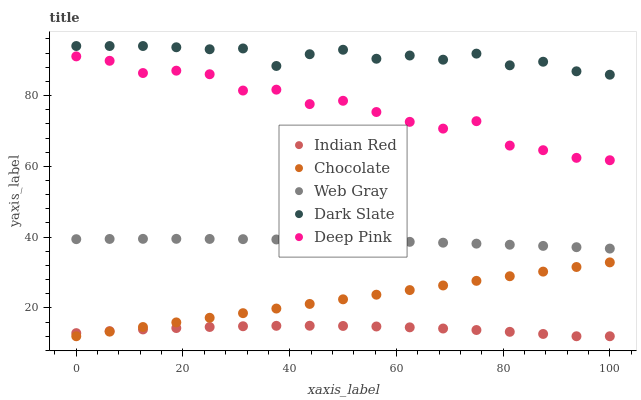Does Indian Red have the minimum area under the curve?
Answer yes or no. Yes. Does Dark Slate have the maximum area under the curve?
Answer yes or no. Yes. Does Web Gray have the minimum area under the curve?
Answer yes or no. No. Does Web Gray have the maximum area under the curve?
Answer yes or no. No. Is Chocolate the smoothest?
Answer yes or no. Yes. Is Deep Pink the roughest?
Answer yes or no. Yes. Is Web Gray the smoothest?
Answer yes or no. No. Is Web Gray the roughest?
Answer yes or no. No. Does Indian Red have the lowest value?
Answer yes or no. Yes. Does Web Gray have the lowest value?
Answer yes or no. No. Does Dark Slate have the highest value?
Answer yes or no. Yes. Does Web Gray have the highest value?
Answer yes or no. No. Is Chocolate less than Web Gray?
Answer yes or no. Yes. Is Web Gray greater than Indian Red?
Answer yes or no. Yes. Does Indian Red intersect Chocolate?
Answer yes or no. Yes. Is Indian Red less than Chocolate?
Answer yes or no. No. Is Indian Red greater than Chocolate?
Answer yes or no. No. Does Chocolate intersect Web Gray?
Answer yes or no. No. 